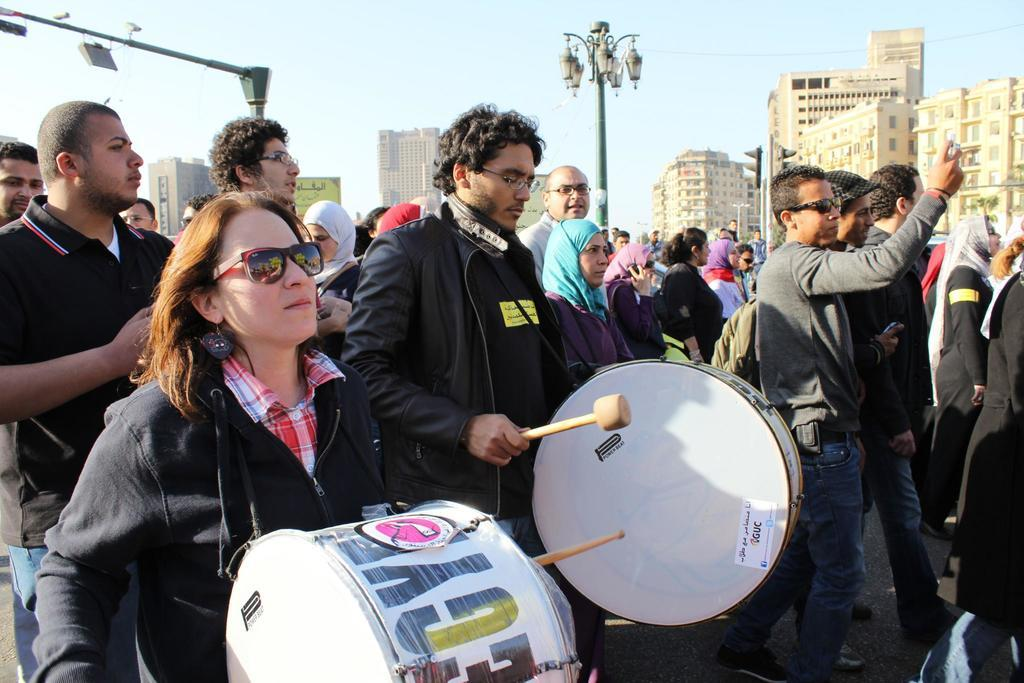What is happening in the image involving a group of people? The group of people are walking. Are there any specific activities being performed by the group of people? Yes, there are two persons playing drums in the image. What can be seen in the background of the image? There are buildings in the background of the image. What type of impulse can be seen affecting the group of people in the image? There is no mention of an impulse affecting the group of people in the image. Can you describe the farmer in the image? There is no farmer present in the image. 